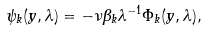Convert formula to latex. <formula><loc_0><loc_0><loc_500><loc_500>\psi _ { k } ( y , \lambda ) = - \nu \beta _ { k } \lambda ^ { - 1 } \Phi _ { k } ( y , \lambda ) ,</formula> 